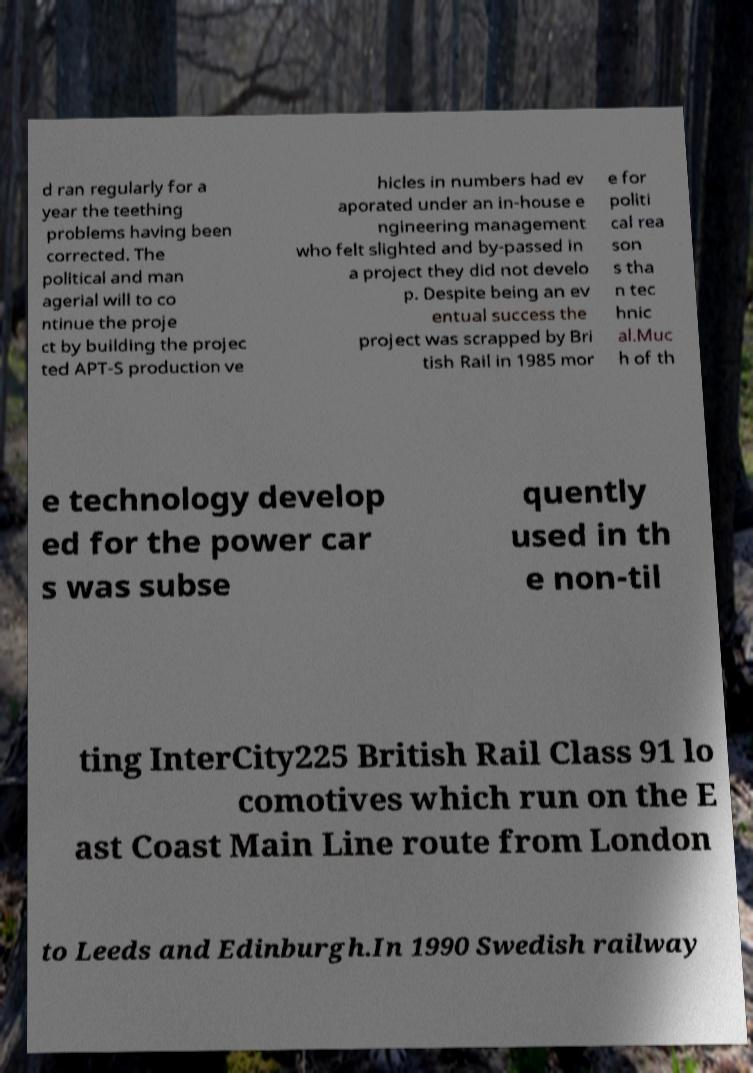For documentation purposes, I need the text within this image transcribed. Could you provide that? d ran regularly for a year the teething problems having been corrected. The political and man agerial will to co ntinue the proje ct by building the projec ted APT-S production ve hicles in numbers had ev aporated under an in-house e ngineering management who felt slighted and by-passed in a project they did not develo p. Despite being an ev entual success the project was scrapped by Bri tish Rail in 1985 mor e for politi cal rea son s tha n tec hnic al.Muc h of th e technology develop ed for the power car s was subse quently used in th e non-til ting InterCity225 British Rail Class 91 lo comotives which run on the E ast Coast Main Line route from London to Leeds and Edinburgh.In 1990 Swedish railway 